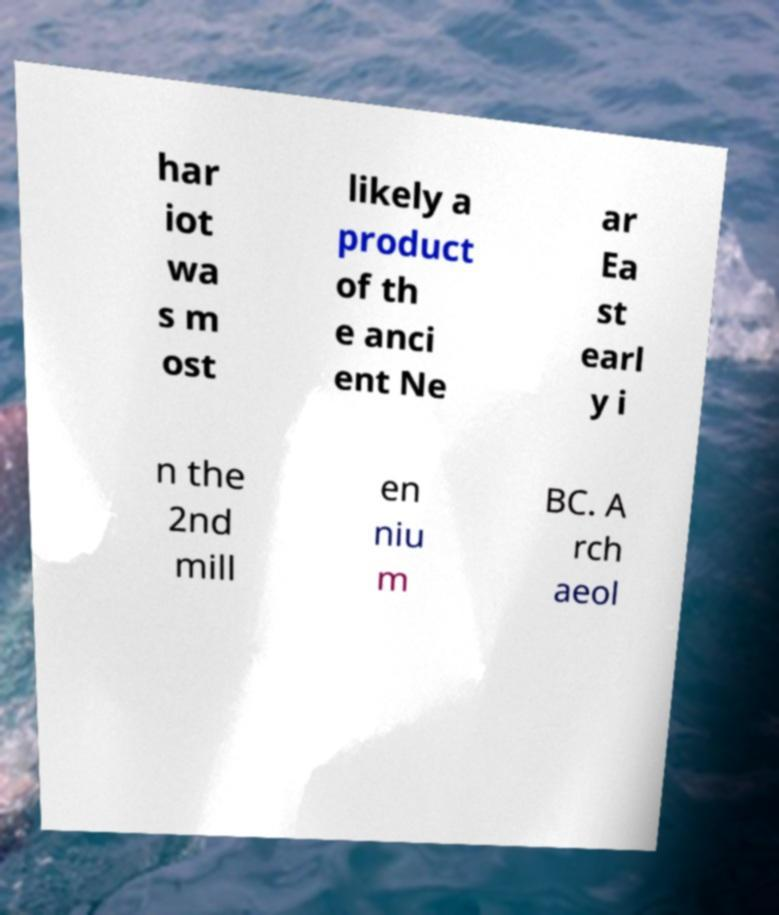I need the written content from this picture converted into text. Can you do that? har iot wa s m ost likely a product of th e anci ent Ne ar Ea st earl y i n the 2nd mill en niu m BC. A rch aeol 